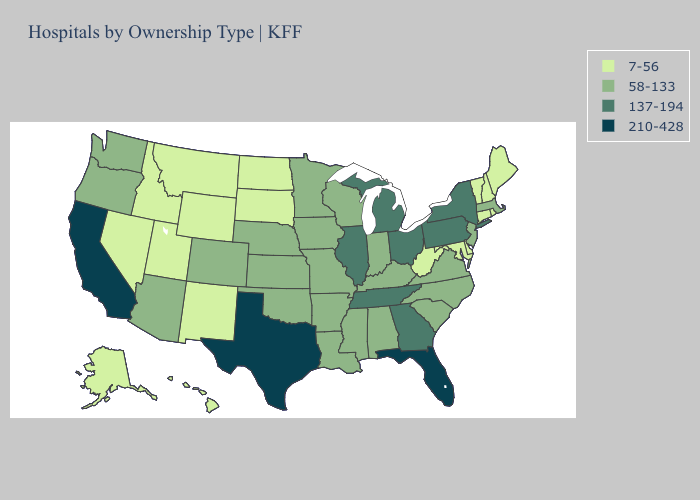Does West Virginia have the highest value in the South?
Be succinct. No. Name the states that have a value in the range 7-56?
Keep it brief. Alaska, Connecticut, Delaware, Hawaii, Idaho, Maine, Maryland, Montana, Nevada, New Hampshire, New Mexico, North Dakota, Rhode Island, South Dakota, Utah, Vermont, West Virginia, Wyoming. Does Texas have the highest value in the USA?
Short answer required. Yes. Name the states that have a value in the range 7-56?
Concise answer only. Alaska, Connecticut, Delaware, Hawaii, Idaho, Maine, Maryland, Montana, Nevada, New Hampshire, New Mexico, North Dakota, Rhode Island, South Dakota, Utah, Vermont, West Virginia, Wyoming. Name the states that have a value in the range 137-194?
Concise answer only. Georgia, Illinois, Michigan, New York, Ohio, Pennsylvania, Tennessee. What is the value of Indiana?
Concise answer only. 58-133. What is the highest value in the South ?
Short answer required. 210-428. Which states have the lowest value in the MidWest?
Keep it brief. North Dakota, South Dakota. What is the value of Maryland?
Keep it brief. 7-56. Among the states that border Delaware , which have the lowest value?
Write a very short answer. Maryland. Does Massachusetts have the highest value in the Northeast?
Answer briefly. No. What is the value of Minnesota?
Quick response, please. 58-133. Which states have the highest value in the USA?
Quick response, please. California, Florida, Texas. Name the states that have a value in the range 210-428?
Short answer required. California, Florida, Texas. 